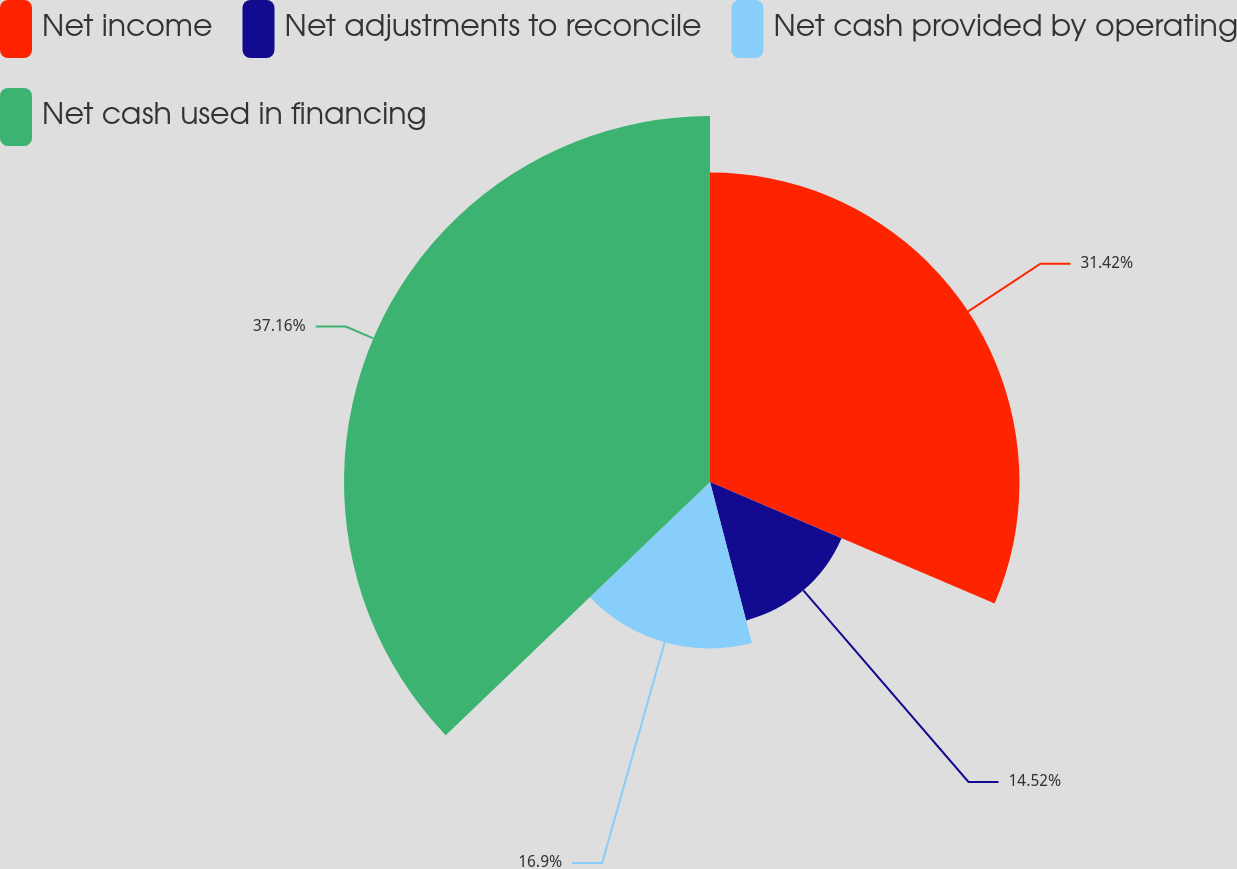Convert chart to OTSL. <chart><loc_0><loc_0><loc_500><loc_500><pie_chart><fcel>Net income<fcel>Net adjustments to reconcile<fcel>Net cash provided by operating<fcel>Net cash used in financing<nl><fcel>31.42%<fcel>14.52%<fcel>16.9%<fcel>37.16%<nl></chart> 